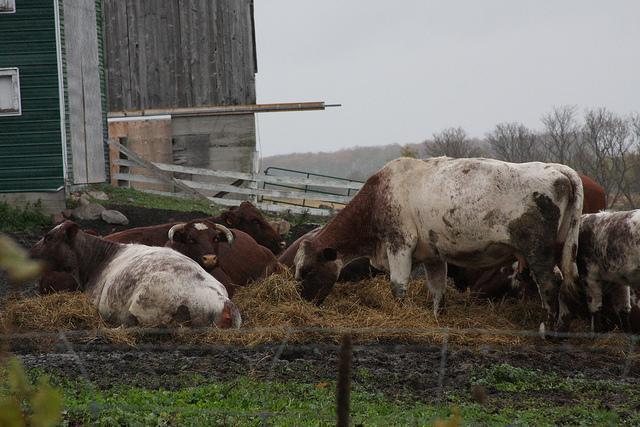The cows main food source for nutrition is brought out in what shape?
From the following four choices, select the correct answer to address the question.
Options: Boxed, bundles, taped, barrels. Barrels. 